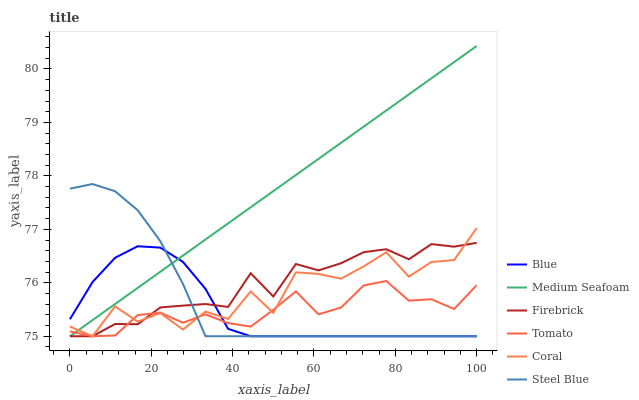Does Blue have the minimum area under the curve?
Answer yes or no. Yes. Does Medium Seafoam have the maximum area under the curve?
Answer yes or no. Yes. Does Tomato have the minimum area under the curve?
Answer yes or no. No. Does Tomato have the maximum area under the curve?
Answer yes or no. No. Is Medium Seafoam the smoothest?
Answer yes or no. Yes. Is Coral the roughest?
Answer yes or no. Yes. Is Tomato the smoothest?
Answer yes or no. No. Is Tomato the roughest?
Answer yes or no. No. Does Blue have the lowest value?
Answer yes or no. Yes. Does Medium Seafoam have the highest value?
Answer yes or no. Yes. Does Firebrick have the highest value?
Answer yes or no. No. Does Firebrick intersect Coral?
Answer yes or no. Yes. Is Firebrick less than Coral?
Answer yes or no. No. Is Firebrick greater than Coral?
Answer yes or no. No. 